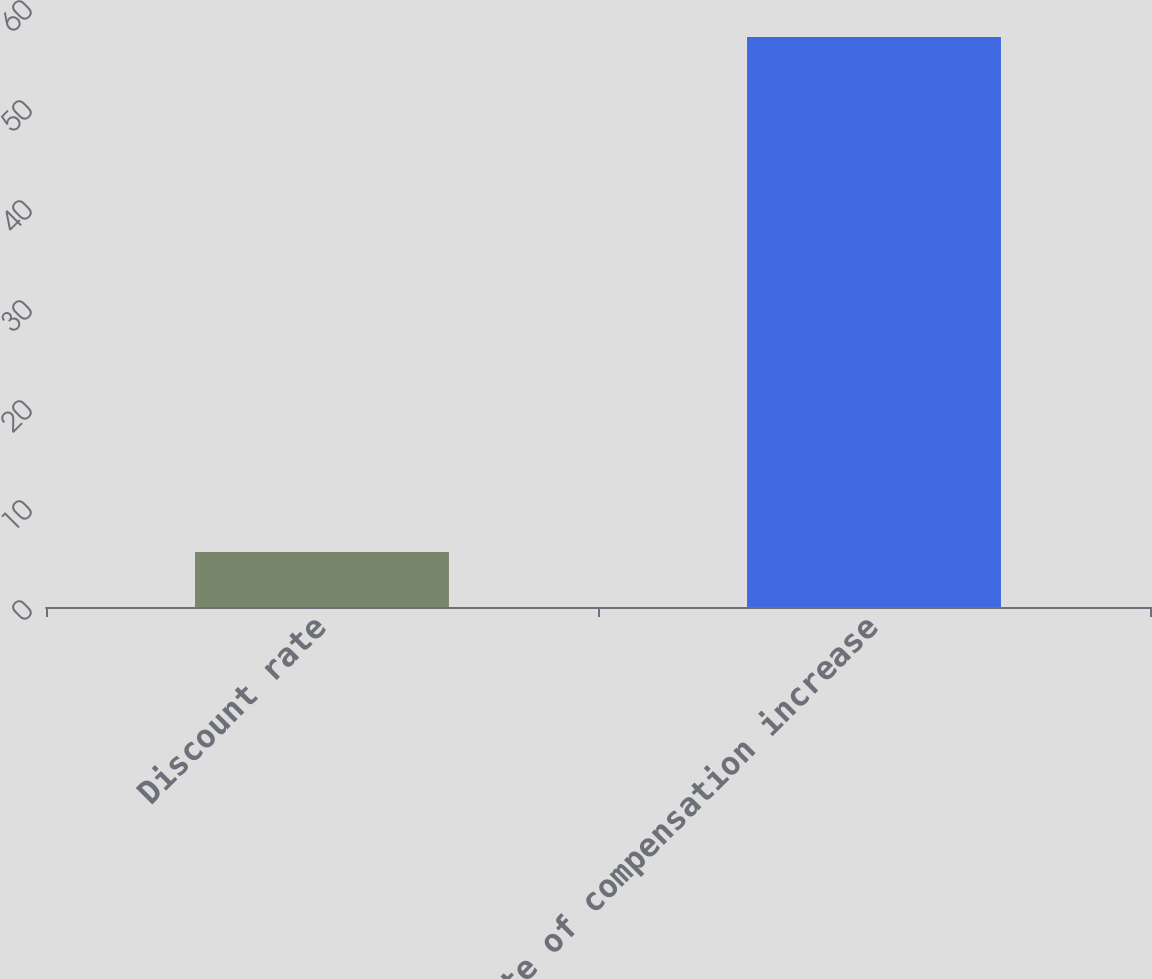Convert chart to OTSL. <chart><loc_0><loc_0><loc_500><loc_500><bar_chart><fcel>Discount rate<fcel>Rate of compensation increase<nl><fcel>5.5<fcel>57<nl></chart> 